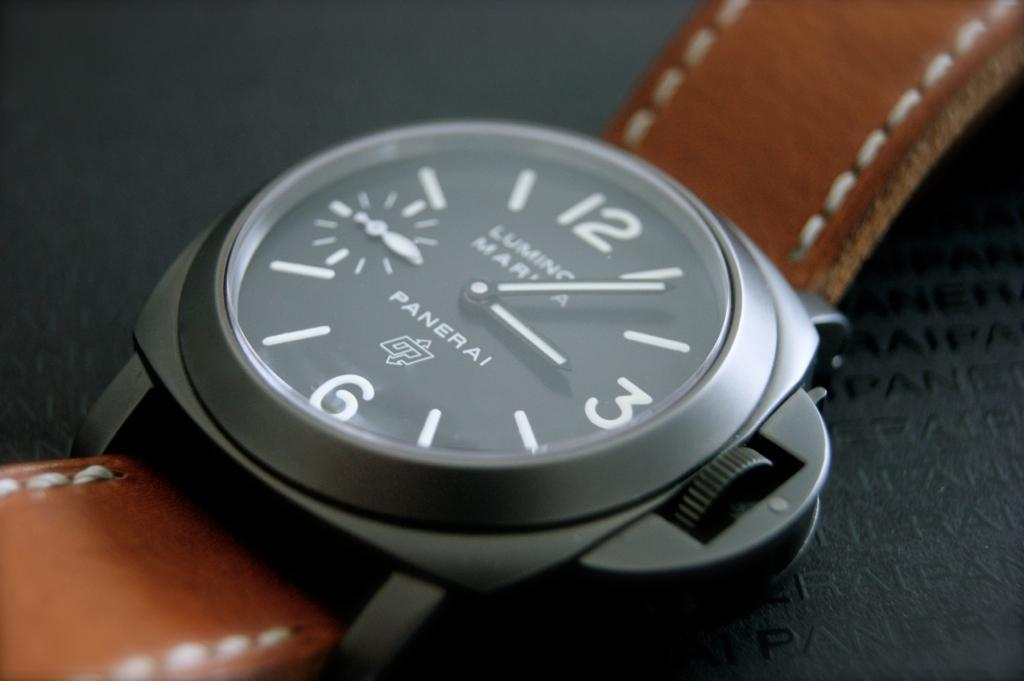<image>
Provide a brief description of the given image. A close up of a Panerai watch with a leather band. 